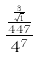<formula> <loc_0><loc_0><loc_500><loc_500>\frac { \frac { \frac { 3 } { \sqrt { 1 } } } { 4 4 7 } } { 4 ^ { 7 } }</formula> 